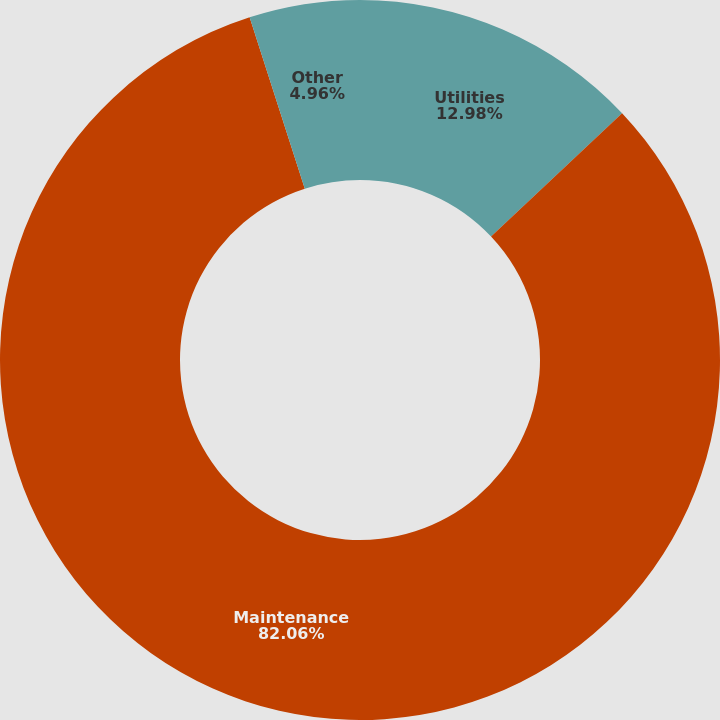Convert chart to OTSL. <chart><loc_0><loc_0><loc_500><loc_500><pie_chart><fcel>Utilities<fcel>Maintenance<fcel>Other<nl><fcel>12.98%<fcel>82.07%<fcel>4.96%<nl></chart> 